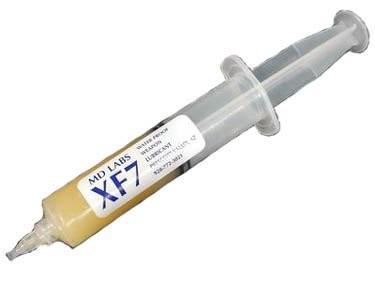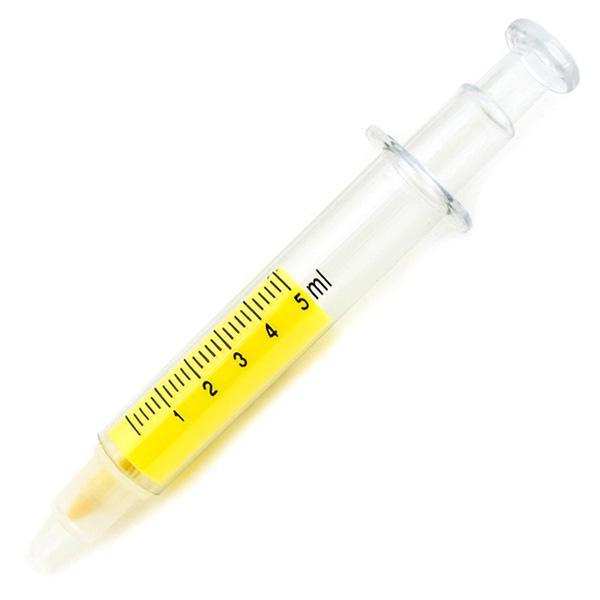The first image is the image on the left, the second image is the image on the right. Given the left and right images, does the statement "there is at least one syringe in the image on the left" hold true? Answer yes or no. Yes. The first image is the image on the left, the second image is the image on the right. For the images shown, is this caption "One of the syringes has a grey plunger." true? Answer yes or no. Yes. 